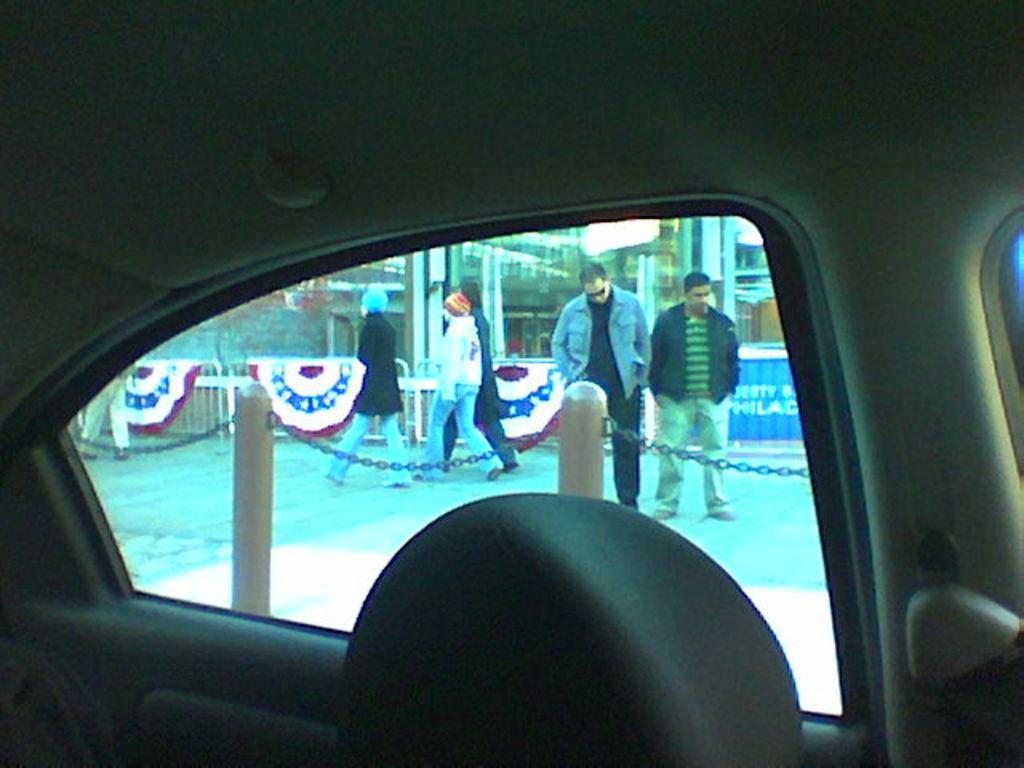How would you summarize this image in a sentence or two? This is a vehicle,inside the vehicle through the glass door we can see few people are walking on the road,fence and glass doors. 